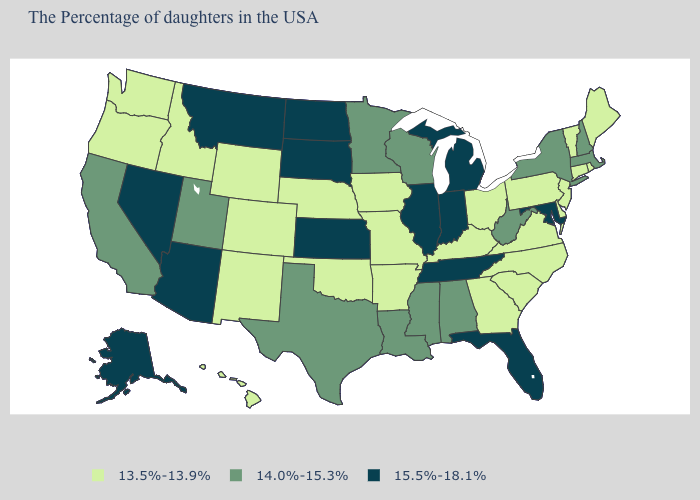Does Connecticut have a lower value than Kentucky?
Write a very short answer. No. What is the lowest value in the USA?
Write a very short answer. 13.5%-13.9%. What is the value of Montana?
Give a very brief answer. 15.5%-18.1%. What is the value of Florida?
Concise answer only. 15.5%-18.1%. What is the value of Oregon?
Keep it brief. 13.5%-13.9%. Among the states that border Indiana , does Illinois have the highest value?
Be succinct. Yes. What is the lowest value in the USA?
Quick response, please. 13.5%-13.9%. What is the value of Oregon?
Answer briefly. 13.5%-13.9%. Among the states that border New York , does New Jersey have the highest value?
Write a very short answer. No. Name the states that have a value in the range 14.0%-15.3%?
Short answer required. Massachusetts, New Hampshire, New York, West Virginia, Alabama, Wisconsin, Mississippi, Louisiana, Minnesota, Texas, Utah, California. What is the value of Kentucky?
Write a very short answer. 13.5%-13.9%. Among the states that border New Jersey , does New York have the highest value?
Answer briefly. Yes. Name the states that have a value in the range 14.0%-15.3%?
Write a very short answer. Massachusetts, New Hampshire, New York, West Virginia, Alabama, Wisconsin, Mississippi, Louisiana, Minnesota, Texas, Utah, California. Does Rhode Island have a lower value than Illinois?
Short answer required. Yes. What is the lowest value in the USA?
Short answer required. 13.5%-13.9%. 